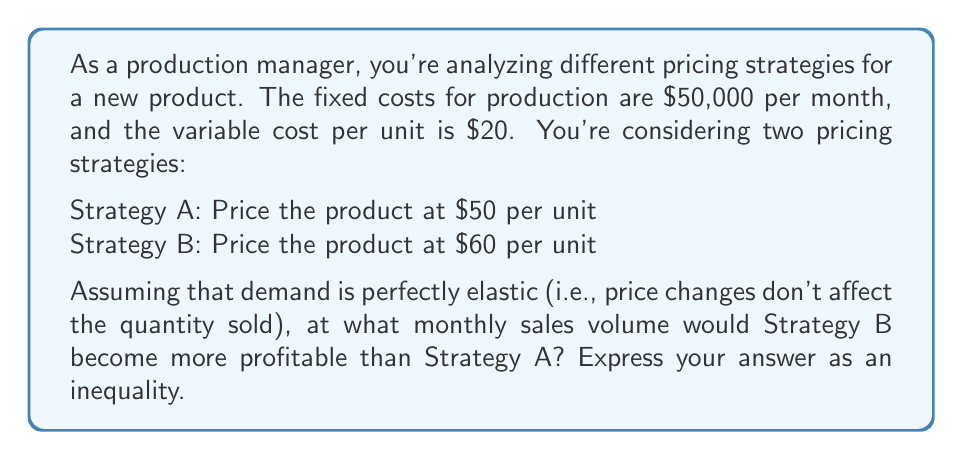Show me your answer to this math problem. Let's approach this step-by-step:

1) First, let's define our variables:
   $x$ = number of units sold per month
   $P_A$ = profit from Strategy A
   $P_B$ = profit from Strategy B

2) We can express the profit for each strategy as:
   $P_A = 50x - 20x - 50000 = 30x - 50000$
   $P_B = 60x - 20x - 50000 = 40x - 50000$

3) Strategy B becomes more profitable when $P_B > P_A$:

   $40x - 50000 > 30x - 50000$

4) Solve the inequality:
   $40x - 50000 > 30x - 50000$
   $40x - 30x > 50000 - 50000$
   $10x > 0$
   $x > 0$

5) This means Strategy B is always more profitable when sales are positive. However, we need to find the break-even point where Strategy B becomes more profitable by a specific amount.

6) Let's say we want Strategy B to be more profitable by at least $y$ dollars:

   $40x - 50000 > 30x - 50000 + y$
   $40x - 30x > y$
   $10x > y$
   $x > \frac{y}{10}$

7) For example, if we want Strategy B to be more profitable by at least $1000, we would have:

   $x > \frac{1000}{10} = 100$

This means Strategy B would be more profitable by at least $1000 when more than 100 units are sold per month.
Answer: Strategy B is more profitable than Strategy A when $x > \frac{y}{10}$, where $x$ is the number of units sold per month and $y$ is the desired profit difference in dollars. 